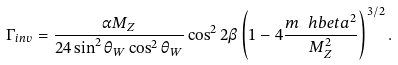Convert formula to latex. <formula><loc_0><loc_0><loc_500><loc_500>\Gamma _ { i n v } = \frac { \alpha M _ { Z } } { 2 4 \sin ^ { 2 } \theta _ { W } \cos ^ { 2 } \theta _ { W } } \cos ^ { 2 } 2 \beta \left ( 1 - 4 \frac { m _ { \ } h b e t a ^ { 2 } } { M _ { Z } ^ { 2 } } \right ) ^ { 3 / 2 } .</formula> 